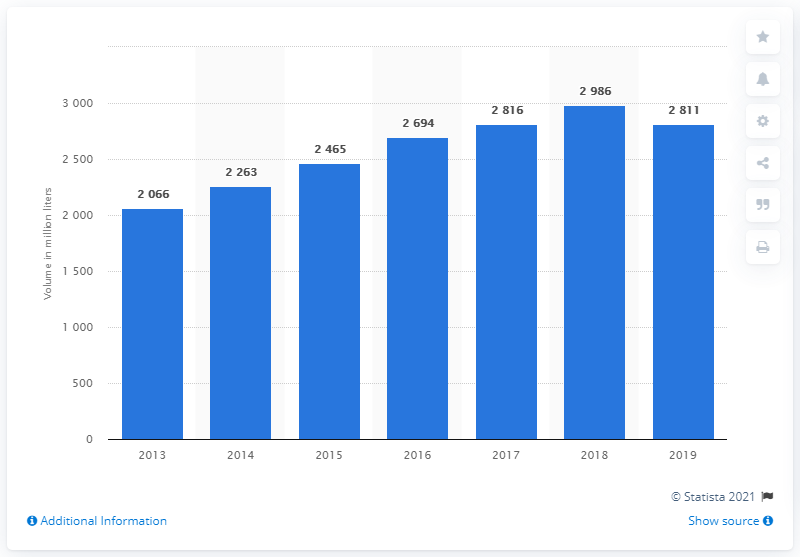Point out several critical features in this image. In 2019, a significant amount of bottled water was consumed in the United Kingdom. Bottled water began to increase in the UK in 2018. 